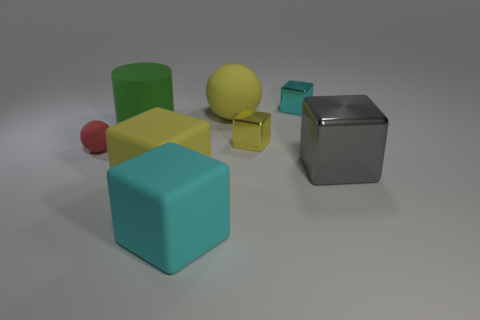Can you tell me the number of cubes and their colors? Certainly! There are three cubes in the image. The colors of the cubes are yellow, teal, and a shiny silver. 